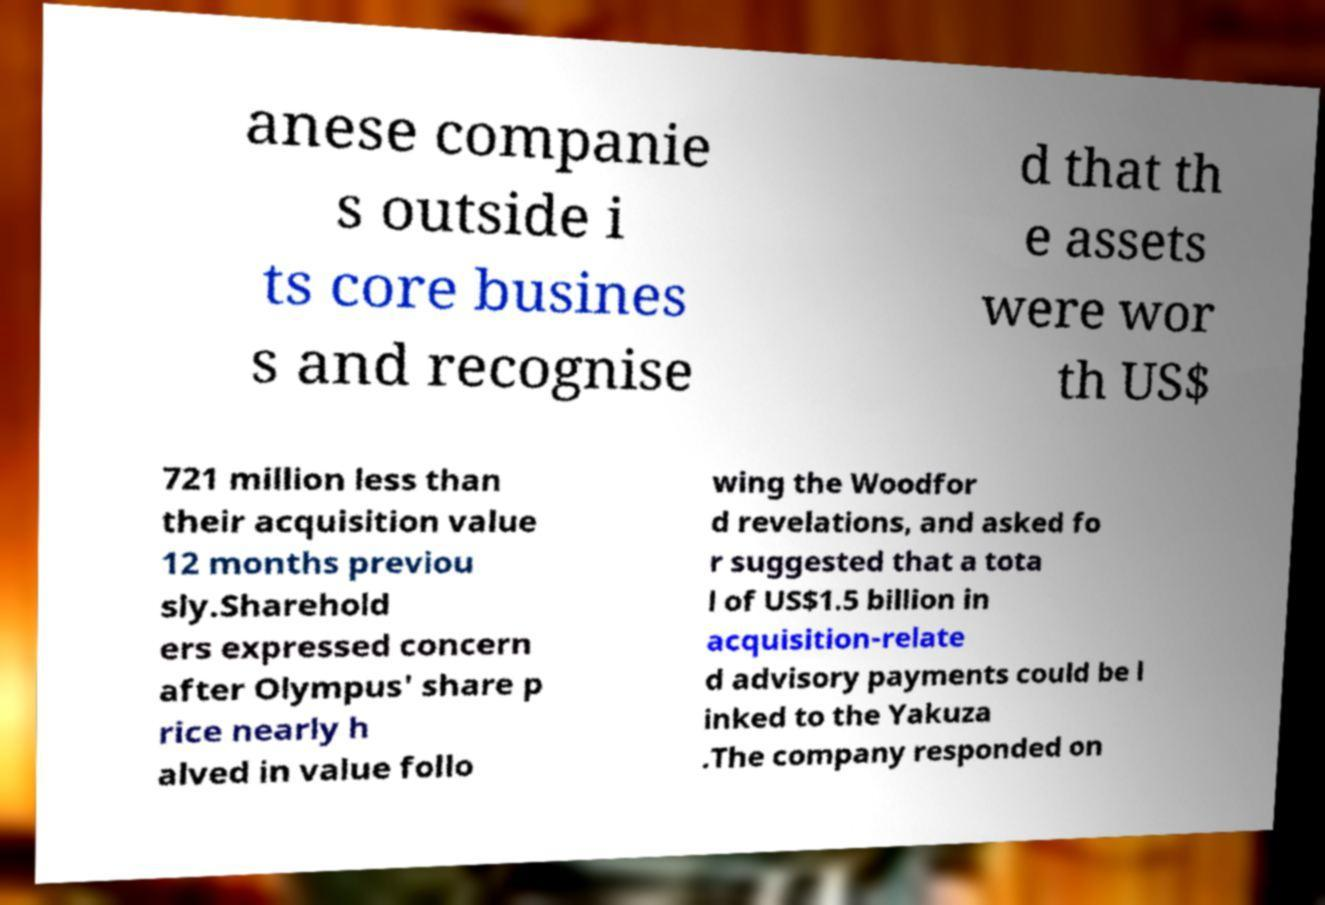I need the written content from this picture converted into text. Can you do that? anese companie s outside i ts core busines s and recognise d that th e assets were wor th US$ 721 million less than their acquisition value 12 months previou sly.Sharehold ers expressed concern after Olympus' share p rice nearly h alved in value follo wing the Woodfor d revelations, and asked fo r suggested that a tota l of US$1.5 billion in acquisition-relate d advisory payments could be l inked to the Yakuza .The company responded on 